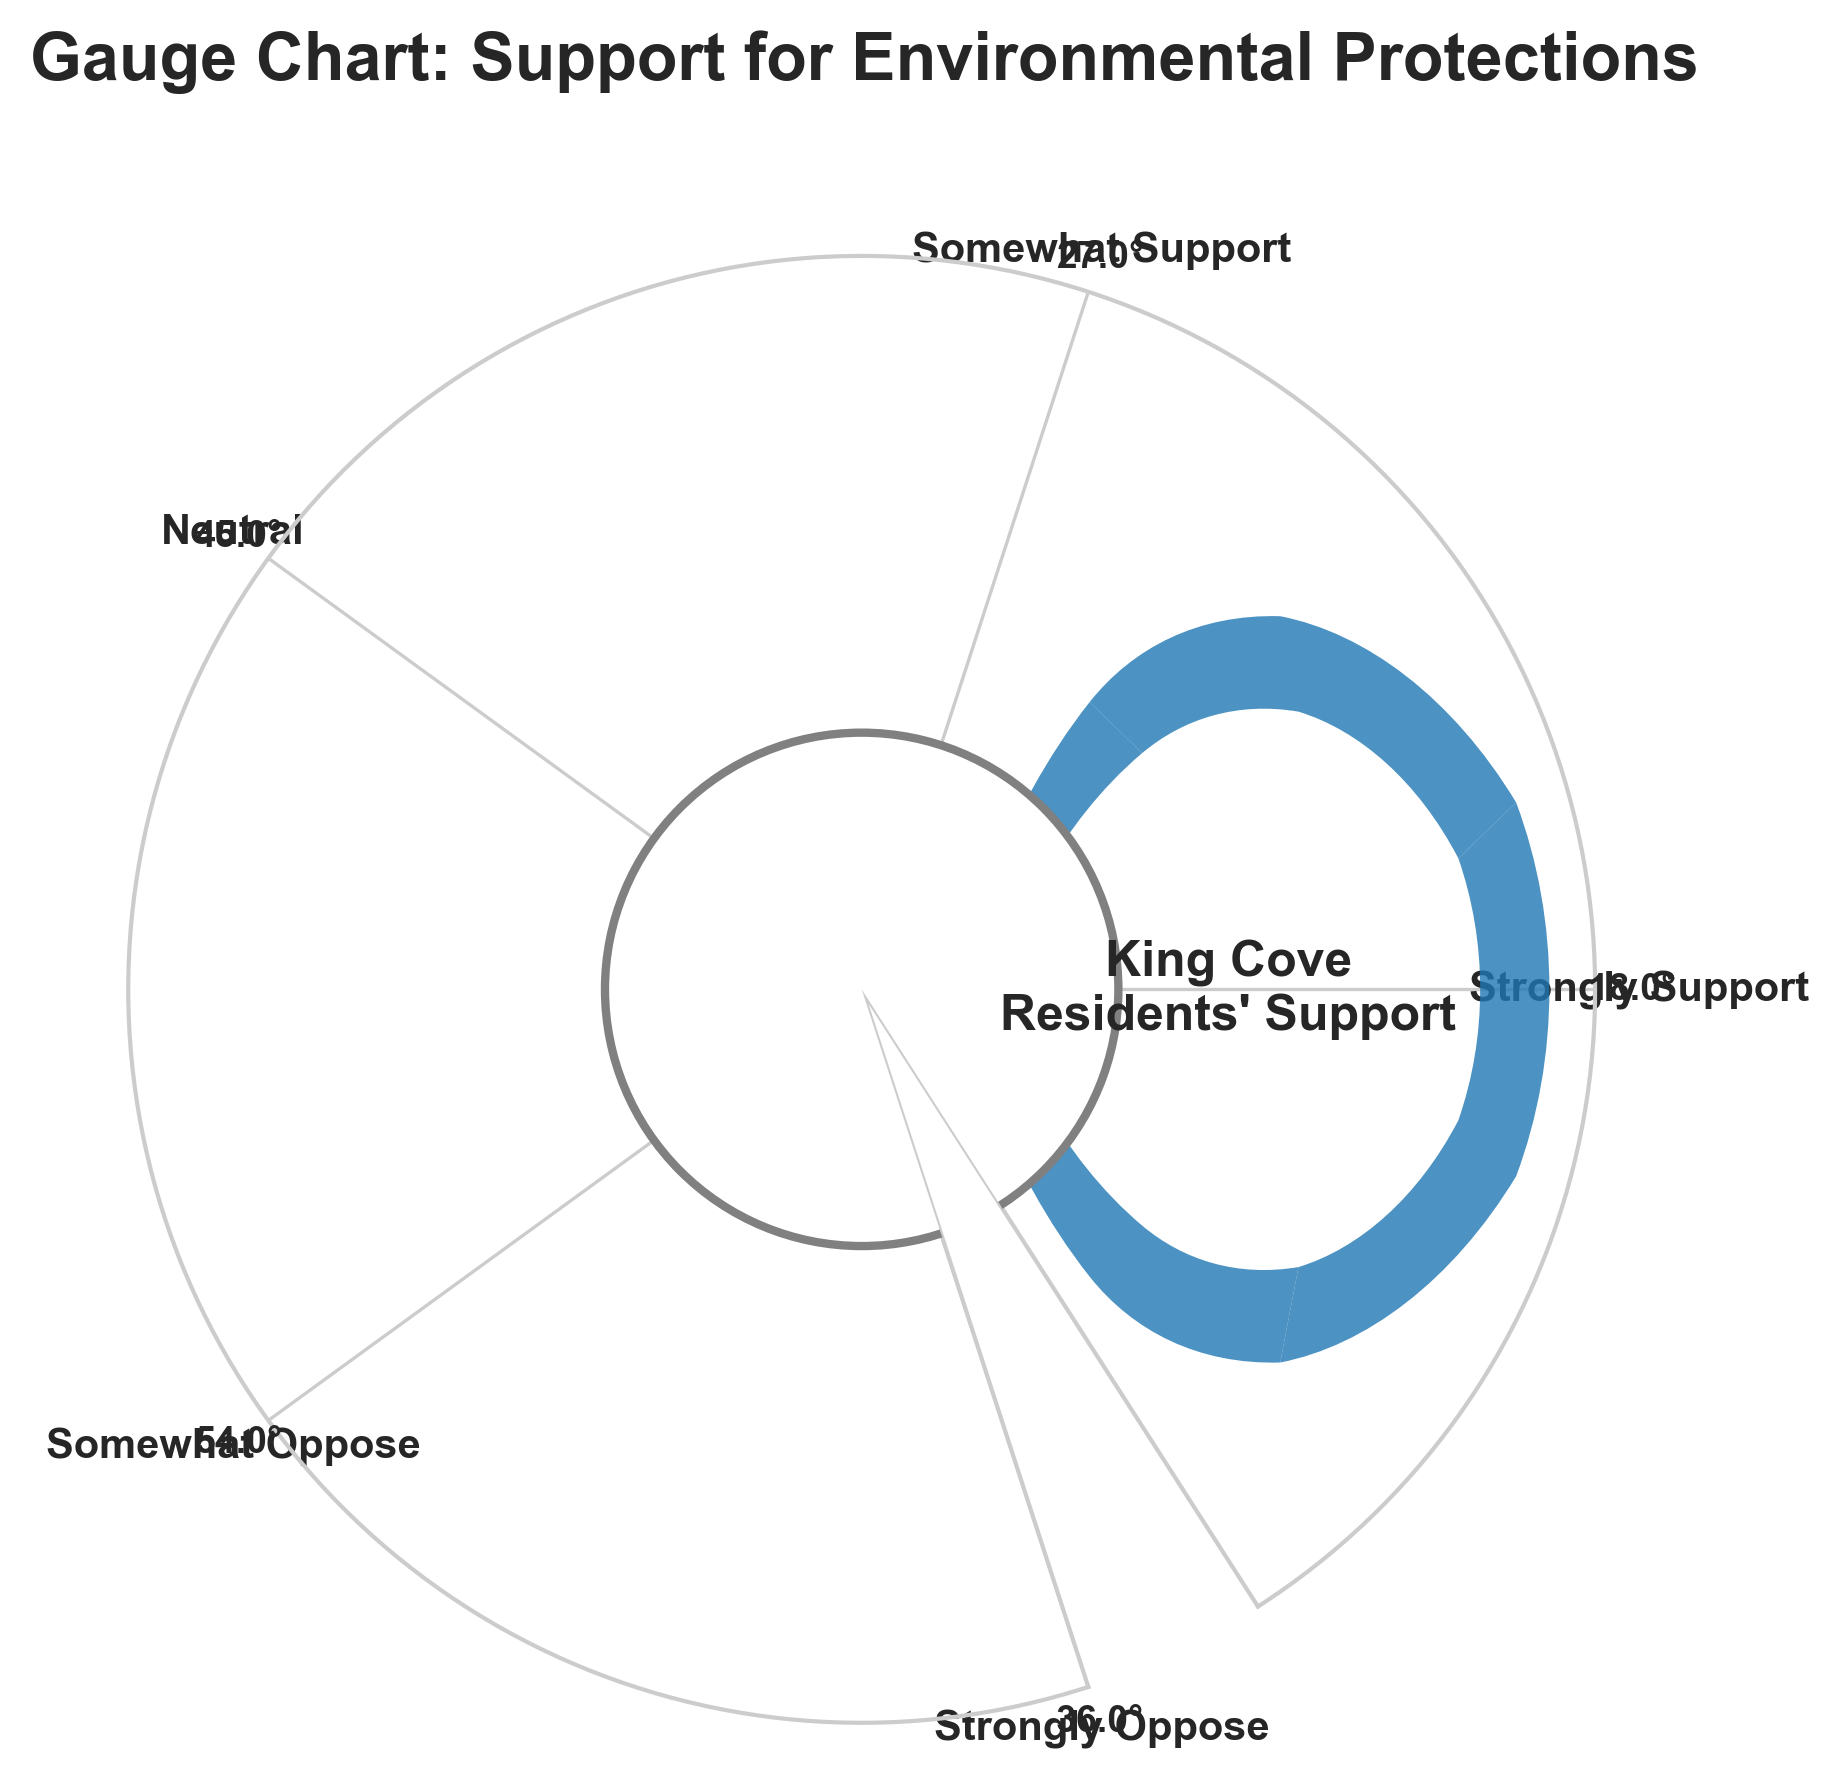What is the title of the figure? The title of the figure is located at the top of the plot.
Answer: Gauge Chart: Support for Environmental Protections How many categories are represented in the figure? The figure shows five distinct colored wedges, each with a labeled category.
Answer: Five Which category shows the highest level of opposition among residents? The categories are labeled around the circle. "Somewhat Oppose" has a larger angle than "Strongly Oppose".
Answer: Somewhat Oppose What percentage of residents are neutral about increased environmental protections? The "Neutral" category is marked with 25%, shown in one of the wedges.
Answer: 25% Among "Strongly Support" and "Somewhat Support", which category has more support? The angles and labels reveal that "Somewhat Support" has 15% whereas "Strongly Support" has 10%.
Answer: Somewhat Support What is the sum percentage of residents who oppose increased environmental protections? Adding "Somewhat Oppose" (30%) and "Strongly Oppose" (20%) gives 30%+20%.
Answer: 50% Is the percentage of residents who somewhat support higher or lower than those who are neutral? The "Somewhat Support" (15%) is compared to "Neutral" (25%), indicating it is lower.
Answer: Lower What is the combined percentage of residents who support increased environmental protections? Adding "Strongly Support" (10%) and "Somewhat Support" (15%) gives 10%+15%.
Answer: 25% How much more in percentage do residents somewhat oppose than strongly oppose increased environmental protections? Subtract "Strongly Oppose" (20%) from "Somewhat Oppose" (30%) gives 30% - 20%.
Answer: 10% What category shows the least percentage of support or opposition, and what is the percentage? The smallest wedge percentage is "Strongly Support" with a 10% label.
Answer: Strongly Support, 10% 